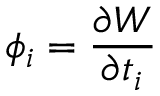<formula> <loc_0><loc_0><loc_500><loc_500>\phi _ { i } = \frac { \partial W } { \partial t _ { i } }</formula> 